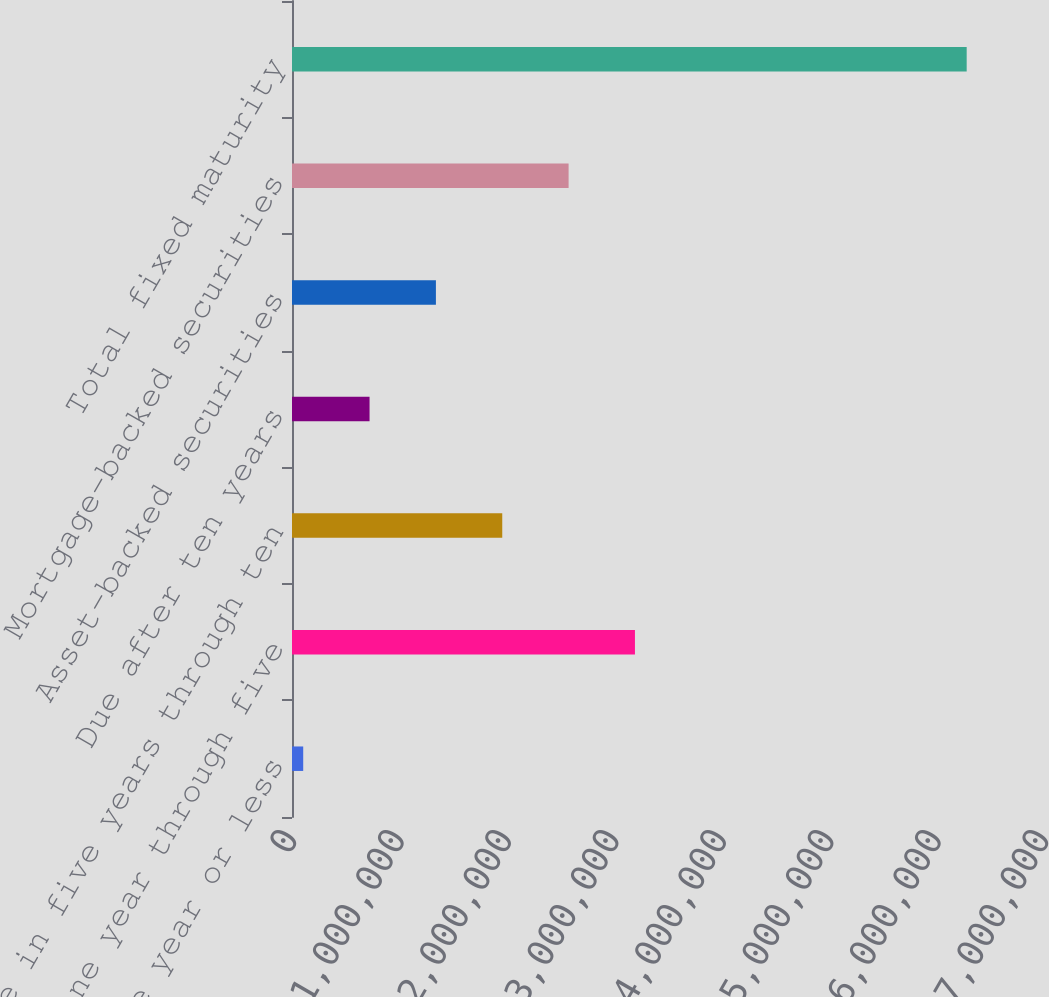<chart> <loc_0><loc_0><loc_500><loc_500><bar_chart><fcel>Due in one year or less<fcel>Due in one year through five<fcel>Due in five years through ten<fcel>Due after ten years<fcel>Asset-backed securities<fcel>Mortgage-backed securities<fcel>Total fixed maturity<nl><fcel>104352<fcel>3.19231e+06<fcel>1.95713e+06<fcel>721944<fcel>1.33954e+06<fcel>2.57472e+06<fcel>6.28028e+06<nl></chart> 